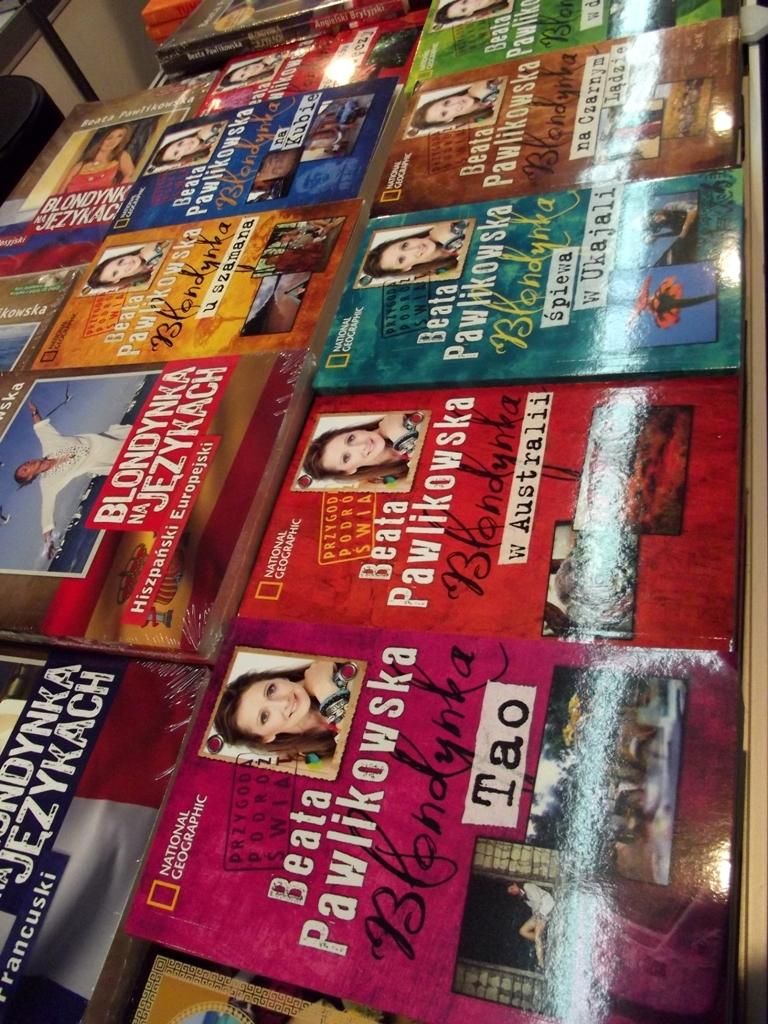Provide a one-sentence caption for the provided image. Bunch of books by Beata pawlikowska on a shelf that is national geographic. 